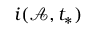Convert formula to latex. <formula><loc_0><loc_0><loc_500><loc_500>i ( \mathcal { A } , t _ { * } )</formula> 